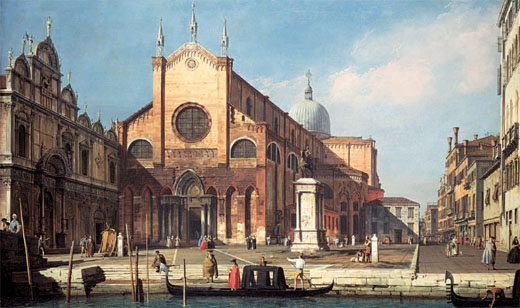Imagine what would happen if this scene suddenly came to life. If this painting suddenly came to life, the once still waters of the canal would begin to ripple as gondolas gently swayed and moved forward. The muted sounds of conversation would grow clearer, filling the air with the hum of daily life. The sun would cast soft light and shadows, adding depth to the scene and bringing warmth to the stone buildings. The scent of fresh bread from a nearby bakery might waft through the air, mingling with the salty tang of the canal. Children would run across the open square, their laughter echoing off the walls. Tourists, with cameras in hand, would capture memories of the stunning architecture and vibrant activity. The church bells would chime, signaling the passing of time and adding a melodious layer to the lively ambiance. It would be a beautiful, animated snapshot of Venice in its full glory. 